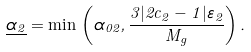Convert formula to latex. <formula><loc_0><loc_0><loc_500><loc_500>\underline { \alpha _ { 2 } } = \min \, \left ( \alpha _ { 0 2 } , \frac { 3 | 2 c _ { 2 } - 1 | \varepsilon _ { 2 } } { M _ { g } } \right ) .</formula> 